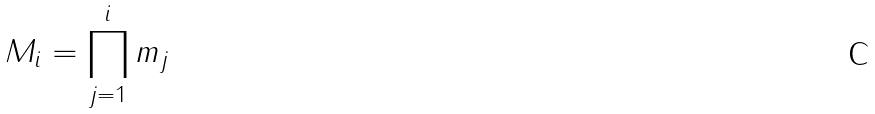<formula> <loc_0><loc_0><loc_500><loc_500>M _ { i } = \prod _ { j = 1 } ^ { i } m _ { j }</formula> 